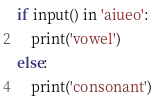Convert code to text. <code><loc_0><loc_0><loc_500><loc_500><_Python_>if input() in 'aiueo':
	print('vowel')
else:
	print('consonant')</code> 